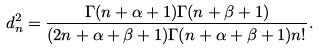<formula> <loc_0><loc_0><loc_500><loc_500>d _ { n } ^ { 2 } = \frac { \Gamma ( n + \alpha + 1 ) \Gamma ( n + \beta + 1 ) } { ( 2 n + \alpha + \beta + 1 ) \Gamma ( n + \alpha + \beta + 1 ) n ! } .</formula> 